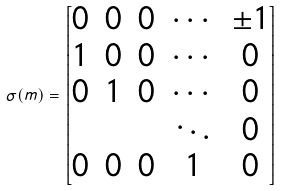<formula> <loc_0><loc_0><loc_500><loc_500>\sigma ( m ) = \begin{bmatrix} 0 & 0 & 0 & \cdots & \pm 1 \\ 1 & 0 & 0 & \cdots & 0 \\ 0 & 1 & 0 & \cdots & 0 \\ & & & \ddots & 0 \\ 0 & 0 & 0 & 1 & 0 \end{bmatrix}</formula> 